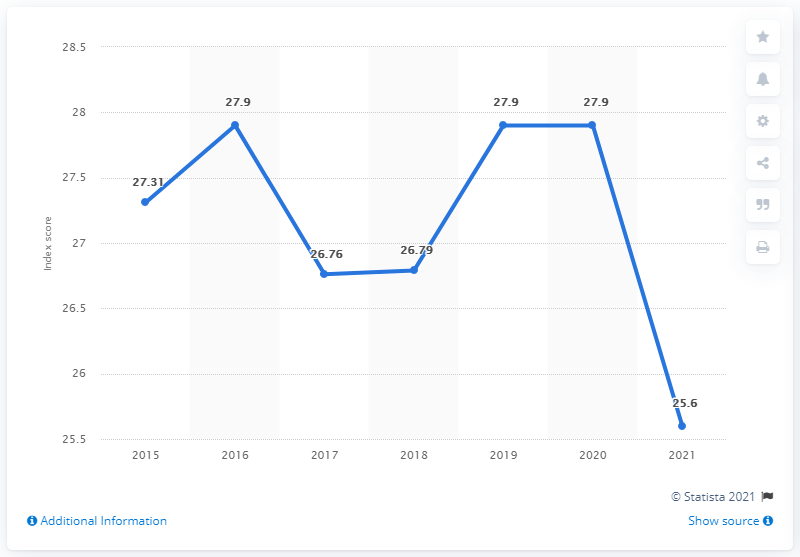Can you tell me how the press freedom index has changed over the last few years according to this graph? As portrayed by the line graph, the Dominican Republic's press freedom index experienced fluctuations over the past years. After increasing from 27.31 in 2015 to 27.9 in 2016, it saw a drop to 26.76 in 2017. It slightly climbed to 26.79 in 2018, held steady at 27.9 in 2019, and then significantly dropped to 25.6 in 2021, marking a decline in press freedom in recent years as per the graph. 